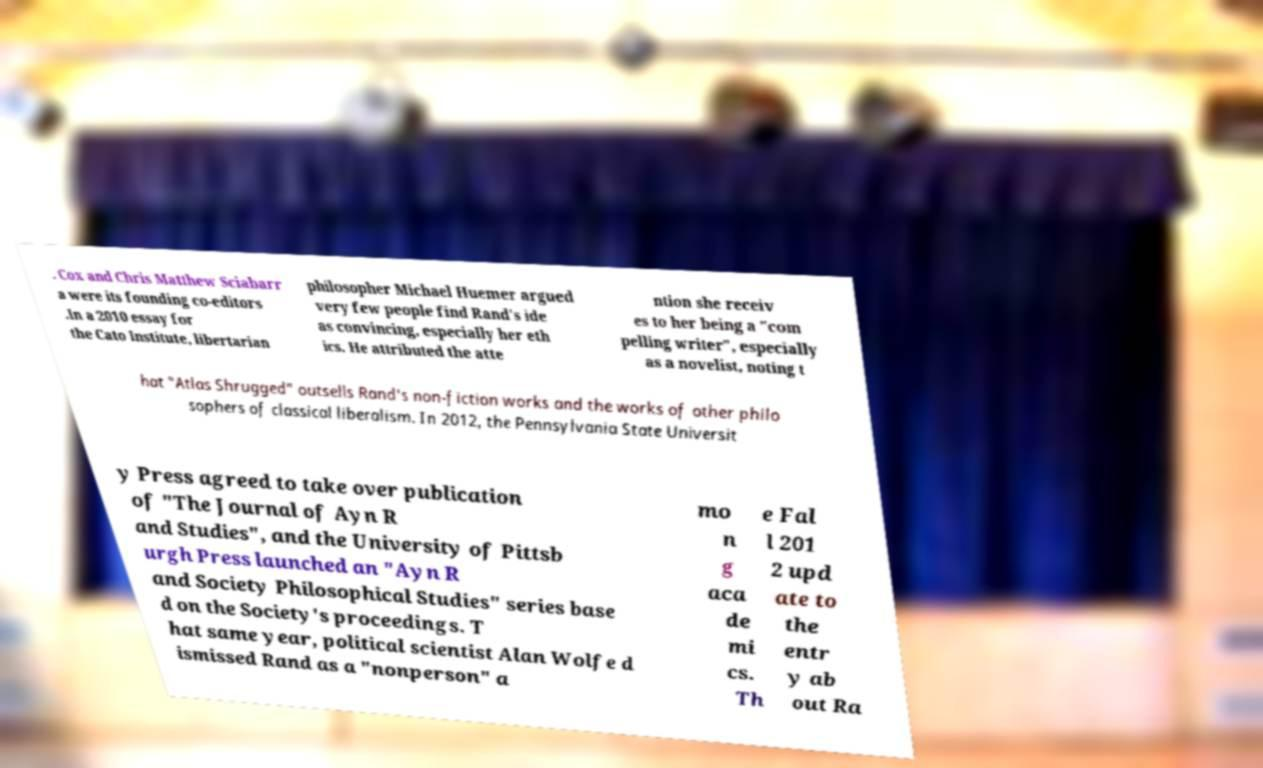What messages or text are displayed in this image? I need them in a readable, typed format. . Cox and Chris Matthew Sciabarr a were its founding co-editors .In a 2010 essay for the Cato Institute, libertarian philosopher Michael Huemer argued very few people find Rand's ide as convincing, especially her eth ics. He attributed the atte ntion she receiv es to her being a "com pelling writer", especially as a novelist, noting t hat "Atlas Shrugged" outsells Rand's non-fiction works and the works of other philo sophers of classical liberalism. In 2012, the Pennsylvania State Universit y Press agreed to take over publication of "The Journal of Ayn R and Studies", and the University of Pittsb urgh Press launched an "Ayn R and Society Philosophical Studies" series base d on the Society's proceedings. T hat same year, political scientist Alan Wolfe d ismissed Rand as a "nonperson" a mo n g aca de mi cs. Th e Fal l 201 2 upd ate to the entr y ab out Ra 